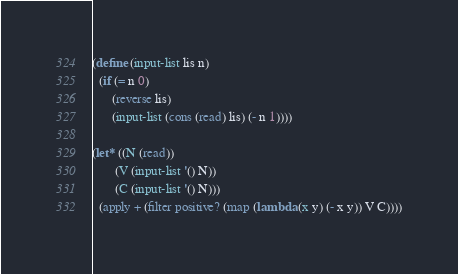Convert code to text. <code><loc_0><loc_0><loc_500><loc_500><_Scheme_>(define (input-list lis n)
  (if (= n 0)
      (reverse lis)
      (input-list (cons (read) lis) (- n 1))))

(let* ((N (read))
       (V (input-list '() N))
       (C (input-list '() N)))
  (apply + (filter positive? (map (lambda (x y) (- x y)) V C))))





</code> 